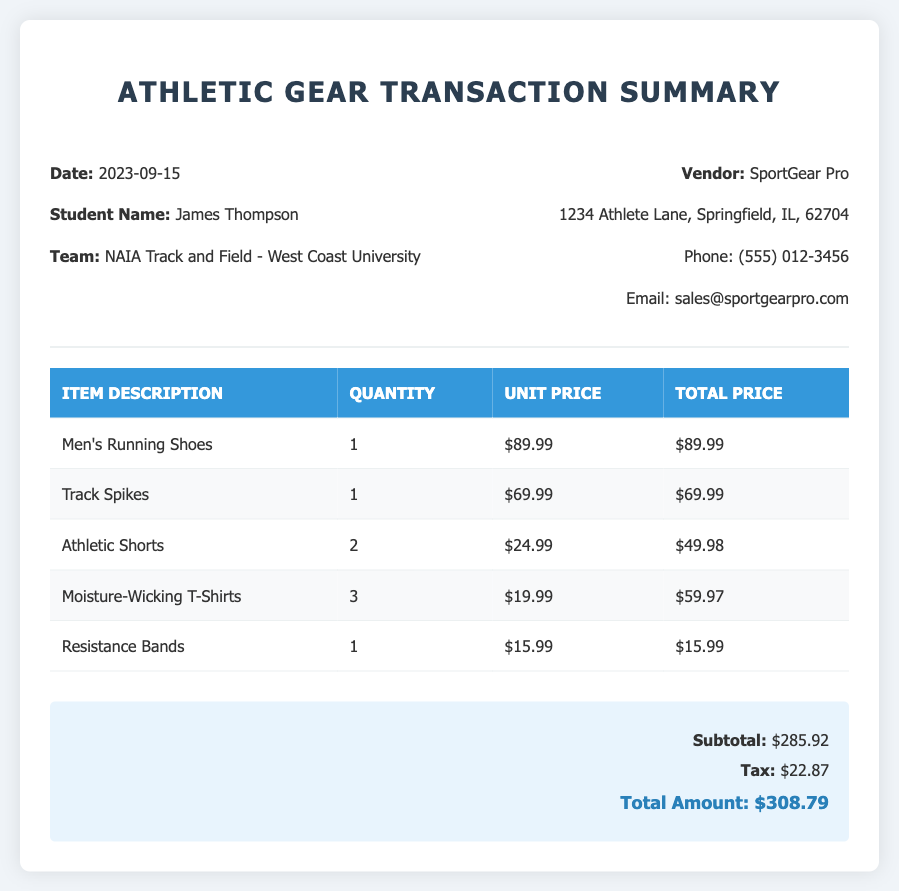What is the transaction date? The transaction date is provided in the header section of the document.
Answer: 2023-09-15 Who is the student? The student's name is listed in the header section under "Student Name."
Answer: James Thompson What is the unit price of Men's Running Shoes? The unit price is located in the itemized table under the respective item description.
Answer: $89.99 How many Moisture-Wicking T-Shirts were purchased? The quantity is found in the itemized table next to the item description.
Answer: 3 What is the name of the vendor? The name of the vendor is identified in the header section of the document.
Answer: SportGear Pro What is the subtotal amount? The subtotal is listed in the summary section at the end of the document.
Answer: $285.92 What are the products purchased in this transaction? The products can be found listed in the itemized table under "Item Description."
Answer: Men's Running Shoes, Track Spikes, Athletic Shorts, Moisture-Wicking T-Shirts, Resistance Bands What is the total amount after tax? The total amount is calculated in the summary section, including subtotal and tax.
Answer: $308.79 What is the tax amount charged? The tax amount is provided in the summary section of the document.
Answer: $22.87 